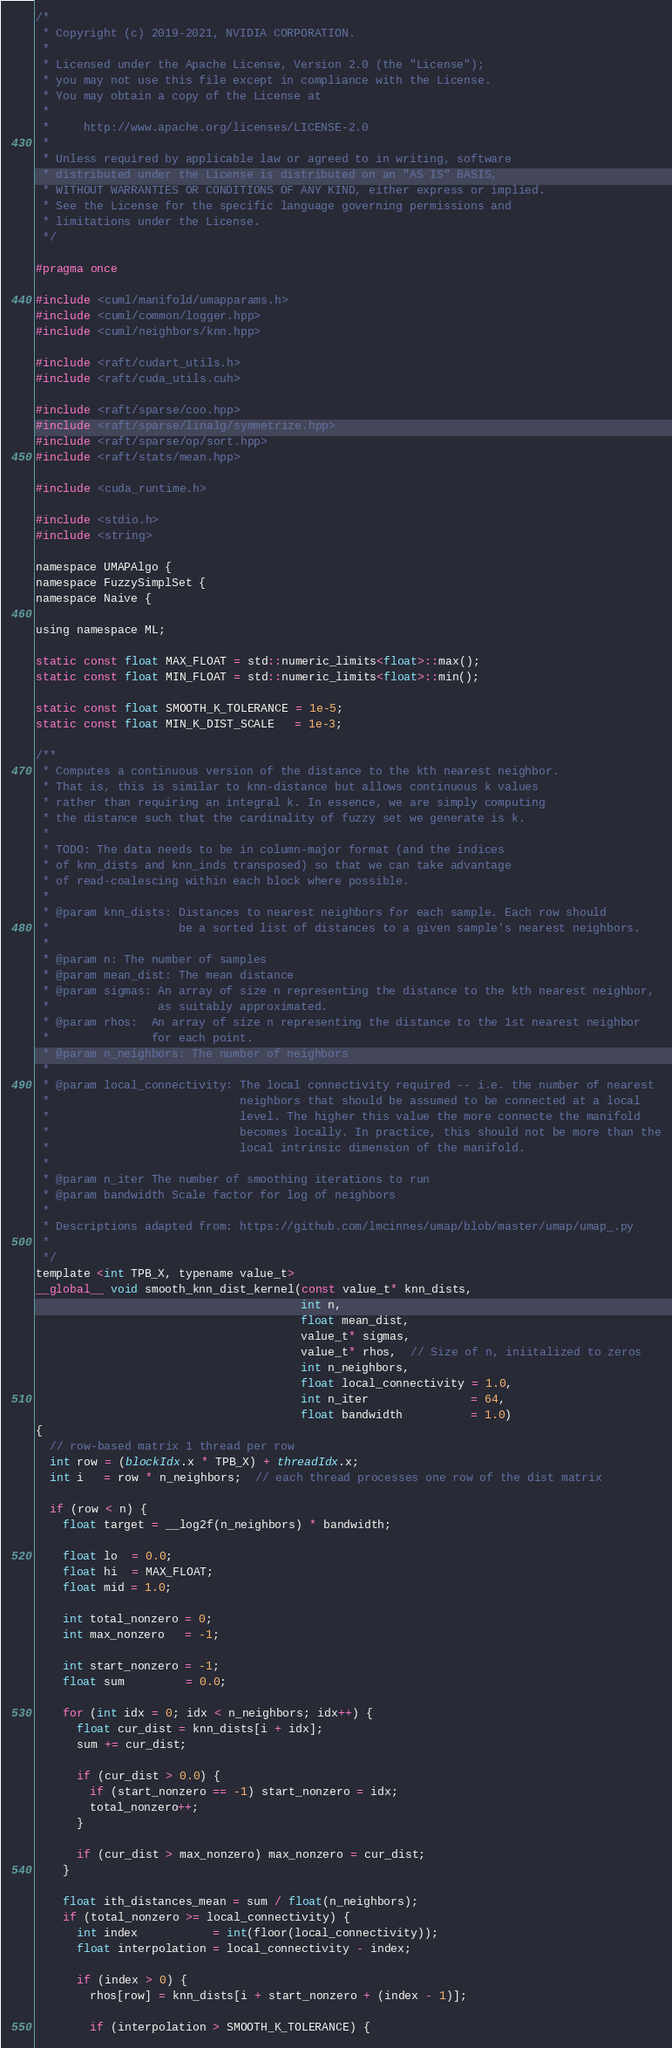Convert code to text. <code><loc_0><loc_0><loc_500><loc_500><_Cuda_>/*
 * Copyright (c) 2019-2021, NVIDIA CORPORATION.
 *
 * Licensed under the Apache License, Version 2.0 (the "License");
 * you may not use this file except in compliance with the License.
 * You may obtain a copy of the License at
 *
 *     http://www.apache.org/licenses/LICENSE-2.0
 *
 * Unless required by applicable law or agreed to in writing, software
 * distributed under the License is distributed on an "AS IS" BASIS,
 * WITHOUT WARRANTIES OR CONDITIONS OF ANY KIND, either express or implied.
 * See the License for the specific language governing permissions and
 * limitations under the License.
 */

#pragma once

#include <cuml/manifold/umapparams.h>
#include <cuml/common/logger.hpp>
#include <cuml/neighbors/knn.hpp>

#include <raft/cudart_utils.h>
#include <raft/cuda_utils.cuh>

#include <raft/sparse/coo.hpp>
#include <raft/sparse/linalg/symmetrize.hpp>
#include <raft/sparse/op/sort.hpp>
#include <raft/stats/mean.hpp>

#include <cuda_runtime.h>

#include <stdio.h>
#include <string>

namespace UMAPAlgo {
namespace FuzzySimplSet {
namespace Naive {

using namespace ML;

static const float MAX_FLOAT = std::numeric_limits<float>::max();
static const float MIN_FLOAT = std::numeric_limits<float>::min();

static const float SMOOTH_K_TOLERANCE = 1e-5;
static const float MIN_K_DIST_SCALE   = 1e-3;

/**
 * Computes a continuous version of the distance to the kth nearest neighbor.
 * That is, this is similar to knn-distance but allows continuous k values
 * rather than requiring an integral k. In essence, we are simply computing
 * the distance such that the cardinality of fuzzy set we generate is k.
 *
 * TODO: The data needs to be in column-major format (and the indices
 * of knn_dists and knn_inds transposed) so that we can take advantage
 * of read-coalescing within each block where possible.
 *
 * @param knn_dists: Distances to nearest neighbors for each sample. Each row should
 *                   be a sorted list of distances to a given sample's nearest neighbors.
 *
 * @param n: The number of samples
 * @param mean_dist: The mean distance
 * @param sigmas: An array of size n representing the distance to the kth nearest neighbor,
 *                as suitably approximated.
 * @param rhos:  An array of size n representing the distance to the 1st nearest neighbor
 *               for each point.
 * @param n_neighbors: The number of neighbors
 *
 * @param local_connectivity: The local connectivity required -- i.e. the number of nearest
 *                            neighbors that should be assumed to be connected at a local
 *                            level. The higher this value the more connecte the manifold
 *                            becomes locally. In practice, this should not be more than the
 *                            local intrinsic dimension of the manifold.
 *
 * @param n_iter The number of smoothing iterations to run
 * @param bandwidth Scale factor for log of neighbors
 *
 * Descriptions adapted from: https://github.com/lmcinnes/umap/blob/master/umap/umap_.py
 *
 */
template <int TPB_X, typename value_t>
__global__ void smooth_knn_dist_kernel(const value_t* knn_dists,
                                       int n,
                                       float mean_dist,
                                       value_t* sigmas,
                                       value_t* rhos,  // Size of n, iniitalized to zeros
                                       int n_neighbors,
                                       float local_connectivity = 1.0,
                                       int n_iter               = 64,
                                       float bandwidth          = 1.0)
{
  // row-based matrix 1 thread per row
  int row = (blockIdx.x * TPB_X) + threadIdx.x;
  int i   = row * n_neighbors;  // each thread processes one row of the dist matrix

  if (row < n) {
    float target = __log2f(n_neighbors) * bandwidth;

    float lo  = 0.0;
    float hi  = MAX_FLOAT;
    float mid = 1.0;

    int total_nonzero = 0;
    int max_nonzero   = -1;

    int start_nonzero = -1;
    float sum         = 0.0;

    for (int idx = 0; idx < n_neighbors; idx++) {
      float cur_dist = knn_dists[i + idx];
      sum += cur_dist;

      if (cur_dist > 0.0) {
        if (start_nonzero == -1) start_nonzero = idx;
        total_nonzero++;
      }

      if (cur_dist > max_nonzero) max_nonzero = cur_dist;
    }

    float ith_distances_mean = sum / float(n_neighbors);
    if (total_nonzero >= local_connectivity) {
      int index           = int(floor(local_connectivity));
      float interpolation = local_connectivity - index;

      if (index > 0) {
        rhos[row] = knn_dists[i + start_nonzero + (index - 1)];

        if (interpolation > SMOOTH_K_TOLERANCE) {</code> 